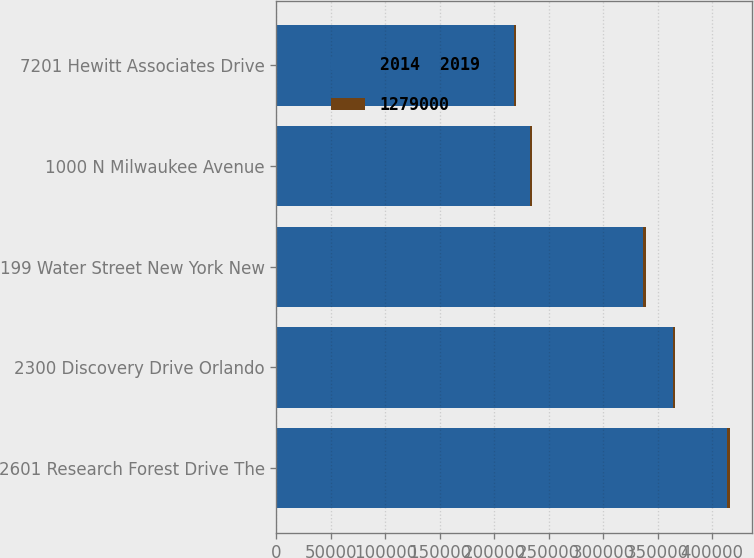<chart> <loc_0><loc_0><loc_500><loc_500><stacked_bar_chart><ecel><fcel>2601 Research Forest Drive The<fcel>2300 Discovery Drive Orlando<fcel>199 Water Street New York New<fcel>1000 N Milwaukee Avenue<fcel>7201 Hewitt Associates Drive<nl><fcel>2014  2019<fcel>414000<fcel>364000<fcel>337000<fcel>233000<fcel>218000<nl><fcel>1279000<fcel>2020<fcel>2020<fcel>2018<fcel>2017<fcel>2015<nl></chart> 